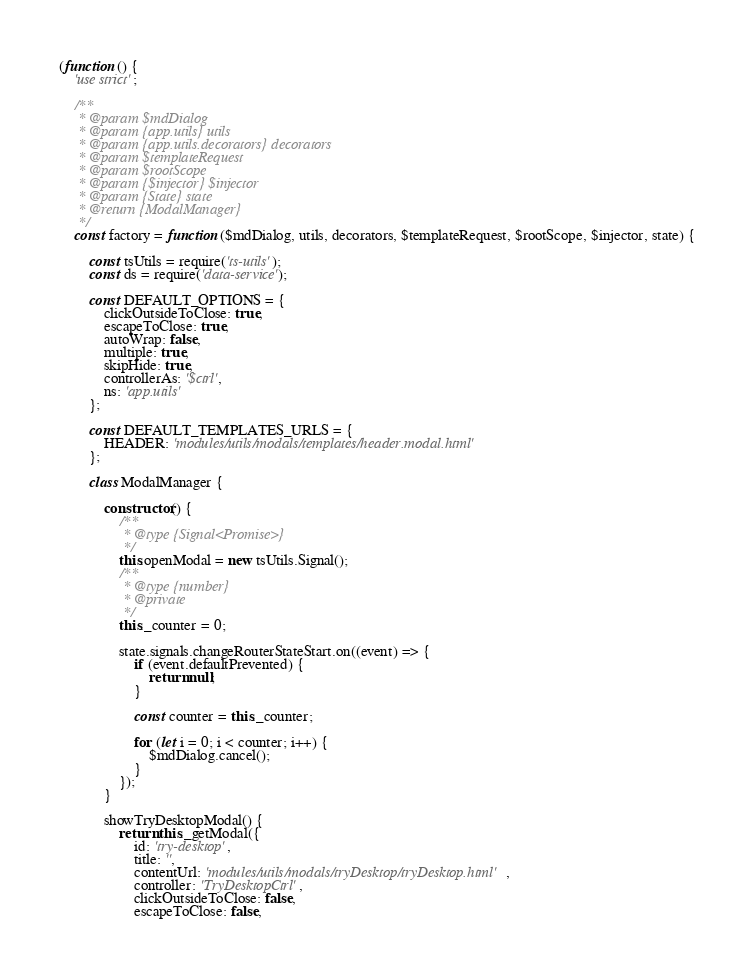Convert code to text. <code><loc_0><loc_0><loc_500><loc_500><_JavaScript_>(function () {
    'use strict';

    /**
     * @param $mdDialog
     * @param {app.utils} utils
     * @param {app.utils.decorators} decorators
     * @param $templateRequest
     * @param $rootScope
     * @param {$injector} $injector
     * @param {State} state
     * @return {ModalManager}
     */
    const factory = function ($mdDialog, utils, decorators, $templateRequest, $rootScope, $injector, state) {

        const tsUtils = require('ts-utils');
        const ds = require('data-service');

        const DEFAULT_OPTIONS = {
            clickOutsideToClose: true,
            escapeToClose: true,
            autoWrap: false,
            multiple: true,
            skipHide: true,
            controllerAs: '$ctrl',
            ns: 'app.utils'
        };

        const DEFAULT_TEMPLATES_URLS = {
            HEADER: 'modules/utils/modals/templates/header.modal.html'
        };

        class ModalManager {

            constructor() {
                /**
                 * @type {Signal<Promise>}
                 */
                this.openModal = new tsUtils.Signal();
                /**
                 * @type {number}
                 * @private
                 */
                this._counter = 0;

                state.signals.changeRouterStateStart.on((event) => {
                    if (event.defaultPrevented) {
                        return null;
                    }

                    const counter = this._counter;

                    for (let i = 0; i < counter; i++) {
                        $mdDialog.cancel();
                    }
                });
            }

            showTryDesktopModal() {
                return this._getModal({
                    id: 'try-desktop',
                    title: '',
                    contentUrl: 'modules/utils/modals/tryDesktop/tryDesktop.html',
                    controller: 'TryDesktopCtrl',
                    clickOutsideToClose: false,
                    escapeToClose: false,</code> 